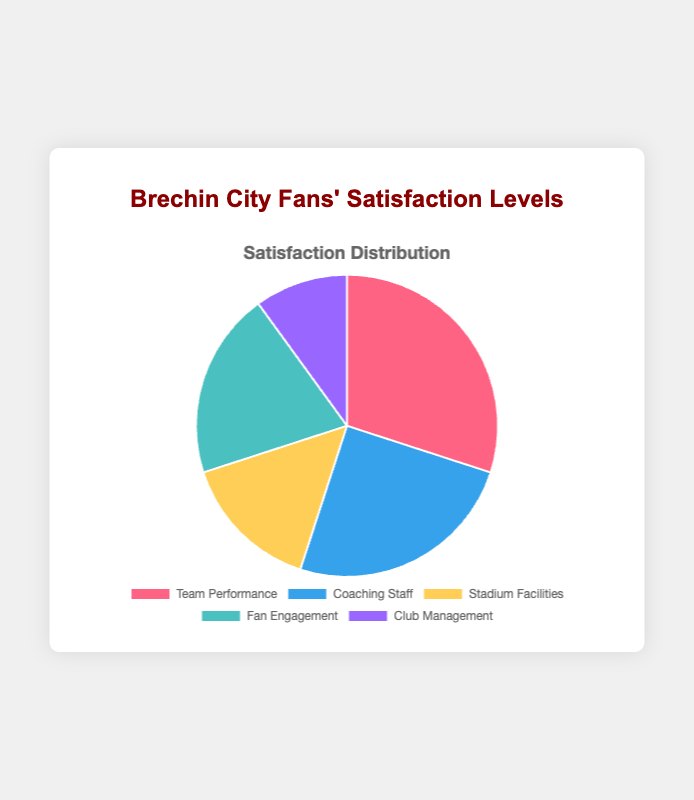What is the aspect with the highest satisfaction level? The figure shows different aspects of satisfaction levels represented by parts of the pie. The largest part corresponds to "Team Performance" which has 30%.
Answer: Team Performance Which aspect has the second highest satisfaction level? By looking at the second largest part of the pie chart, we find that "Coaching Staff" comes next to "Team Performance" with a satisfaction level of 25%.
Answer: Coaching Staff What is the combined satisfaction level for "Stadium Facilities" and "Fan Engagement"? Sum the satisfaction levels of "Stadium Facilities" (15%) and "Fan Engagement" (20%). 15% + 20% equals 35%.
Answer: 35% Which aspects have satisfaction levels less than 20%? The pie chart shows satisfaction levels for each aspect. "Stadium Facilities" has 15% and "Club Management" has 10%, both of which are less than 20%.
Answer: Stadium Facilities, Club Management What is the difference in satisfaction level between "Team Performance" and "Club Management"? Subtract the satisfaction level of "Club Management" (10%) from "Team Performance" (30%), which results in 30% - 10% = 20%.
Answer: 20% How much greater is the satisfaction level for "Coaching Staff" compared to "Club Management"? Subtract the satisfaction level of "Club Management" (10%) from "Coaching Staff" (25%), which results in 25% - 10% = 15%.
Answer: 15% What is the average satisfaction level for all aspects? Sum all satisfaction levels (30% + 25% + 15% + 20% + 10% = 100%) and divide by the number of aspects (5). The average satisfaction level is 100% / 5 = 20%.
Answer: 20% What is the total satisfaction level for aspects with satisfaction levels greater than 15%? Sum the satisfaction levels of "Team Performance" (30%), "Coaching Staff" (25%), and "Fan Engagement" (20%), which are all greater than 15%. The total is 30% + 25% + 20% = 75%.
Answer: 75% Which aspect has the smallest satisfaction level and what is its value? The pie chart shows the smallest part corresponding to "Club Management," which has a satisfaction level of 10%.
Answer: Club Management, 10% What is the ratio of satisfaction levels between "Fan Engagement" and "Stadium Facilities"? Divide the satisfaction level of "Fan Engagement" (20%) by "Stadium Facilities" (15%). The ratio is 20% / 15%, which simplifies to 4/3 or approximately 1.33.
Answer: 1.33 